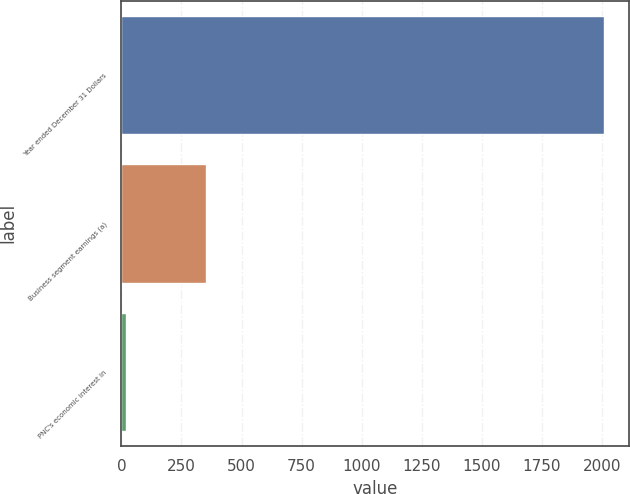<chart> <loc_0><loc_0><loc_500><loc_500><bar_chart><fcel>Year ended December 31 Dollars<fcel>Business segment earnings (a)<fcel>PNC's economic interest in<nl><fcel>2010<fcel>351<fcel>20<nl></chart> 